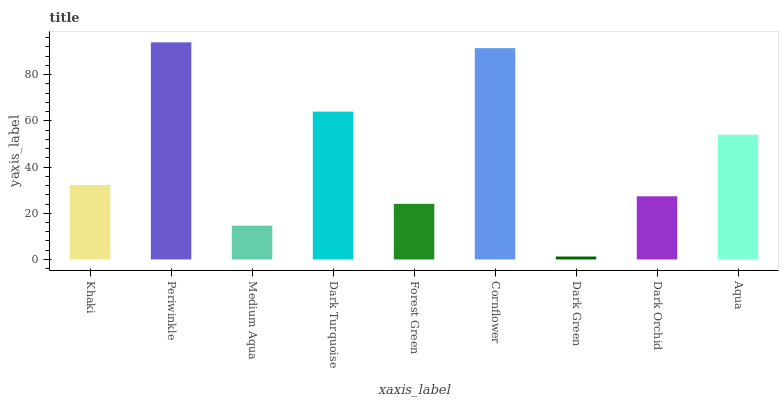Is Medium Aqua the minimum?
Answer yes or no. No. Is Medium Aqua the maximum?
Answer yes or no. No. Is Periwinkle greater than Medium Aqua?
Answer yes or no. Yes. Is Medium Aqua less than Periwinkle?
Answer yes or no. Yes. Is Medium Aqua greater than Periwinkle?
Answer yes or no. No. Is Periwinkle less than Medium Aqua?
Answer yes or no. No. Is Khaki the high median?
Answer yes or no. Yes. Is Khaki the low median?
Answer yes or no. Yes. Is Medium Aqua the high median?
Answer yes or no. No. Is Forest Green the low median?
Answer yes or no. No. 